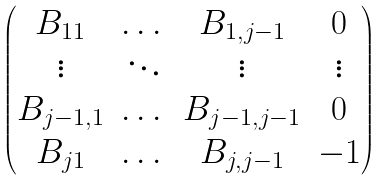<formula> <loc_0><loc_0><loc_500><loc_500>\begin{pmatrix} B _ { 1 1 } & \dots & B _ { 1 , j - 1 } & 0 \\ \vdots & \ddots & \vdots & \vdots \\ B _ { j - 1 , 1 } & \dots & B _ { j - 1 , j - 1 } & 0 \\ B _ { j 1 } & \dots & B _ { j , j - 1 } & - 1 \end{pmatrix}</formula> 